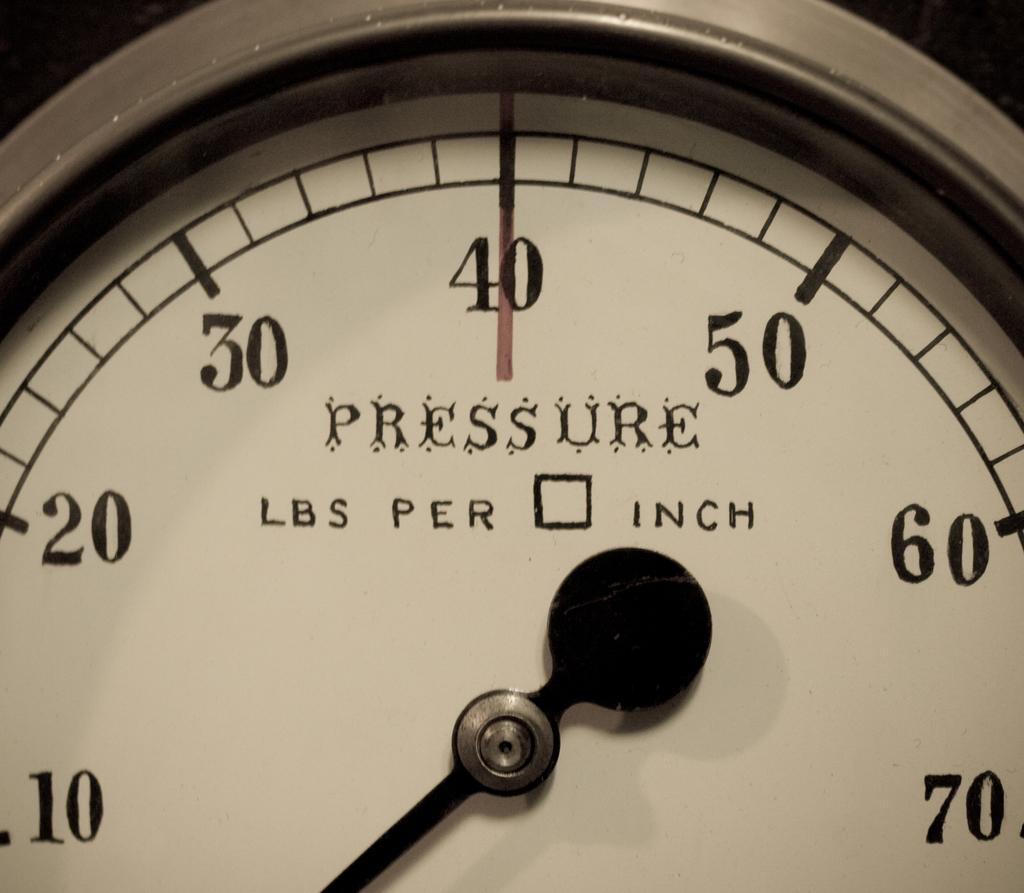What is the main object in the image? There is a meter in the image. What feature of the meter is visible in the image? The meter has an indicator. What information can be found on the frame of the meter? There are numbers and text on the frame of the meter. Can you tell me how many flowers are depicted on the meter in the image? There are no flowers depicted on the meter in the image; it only features numbers, text, and an indicator. Is there a writer sitting next to the meter in the image? There is no writer present in the image; it only features the meter. 